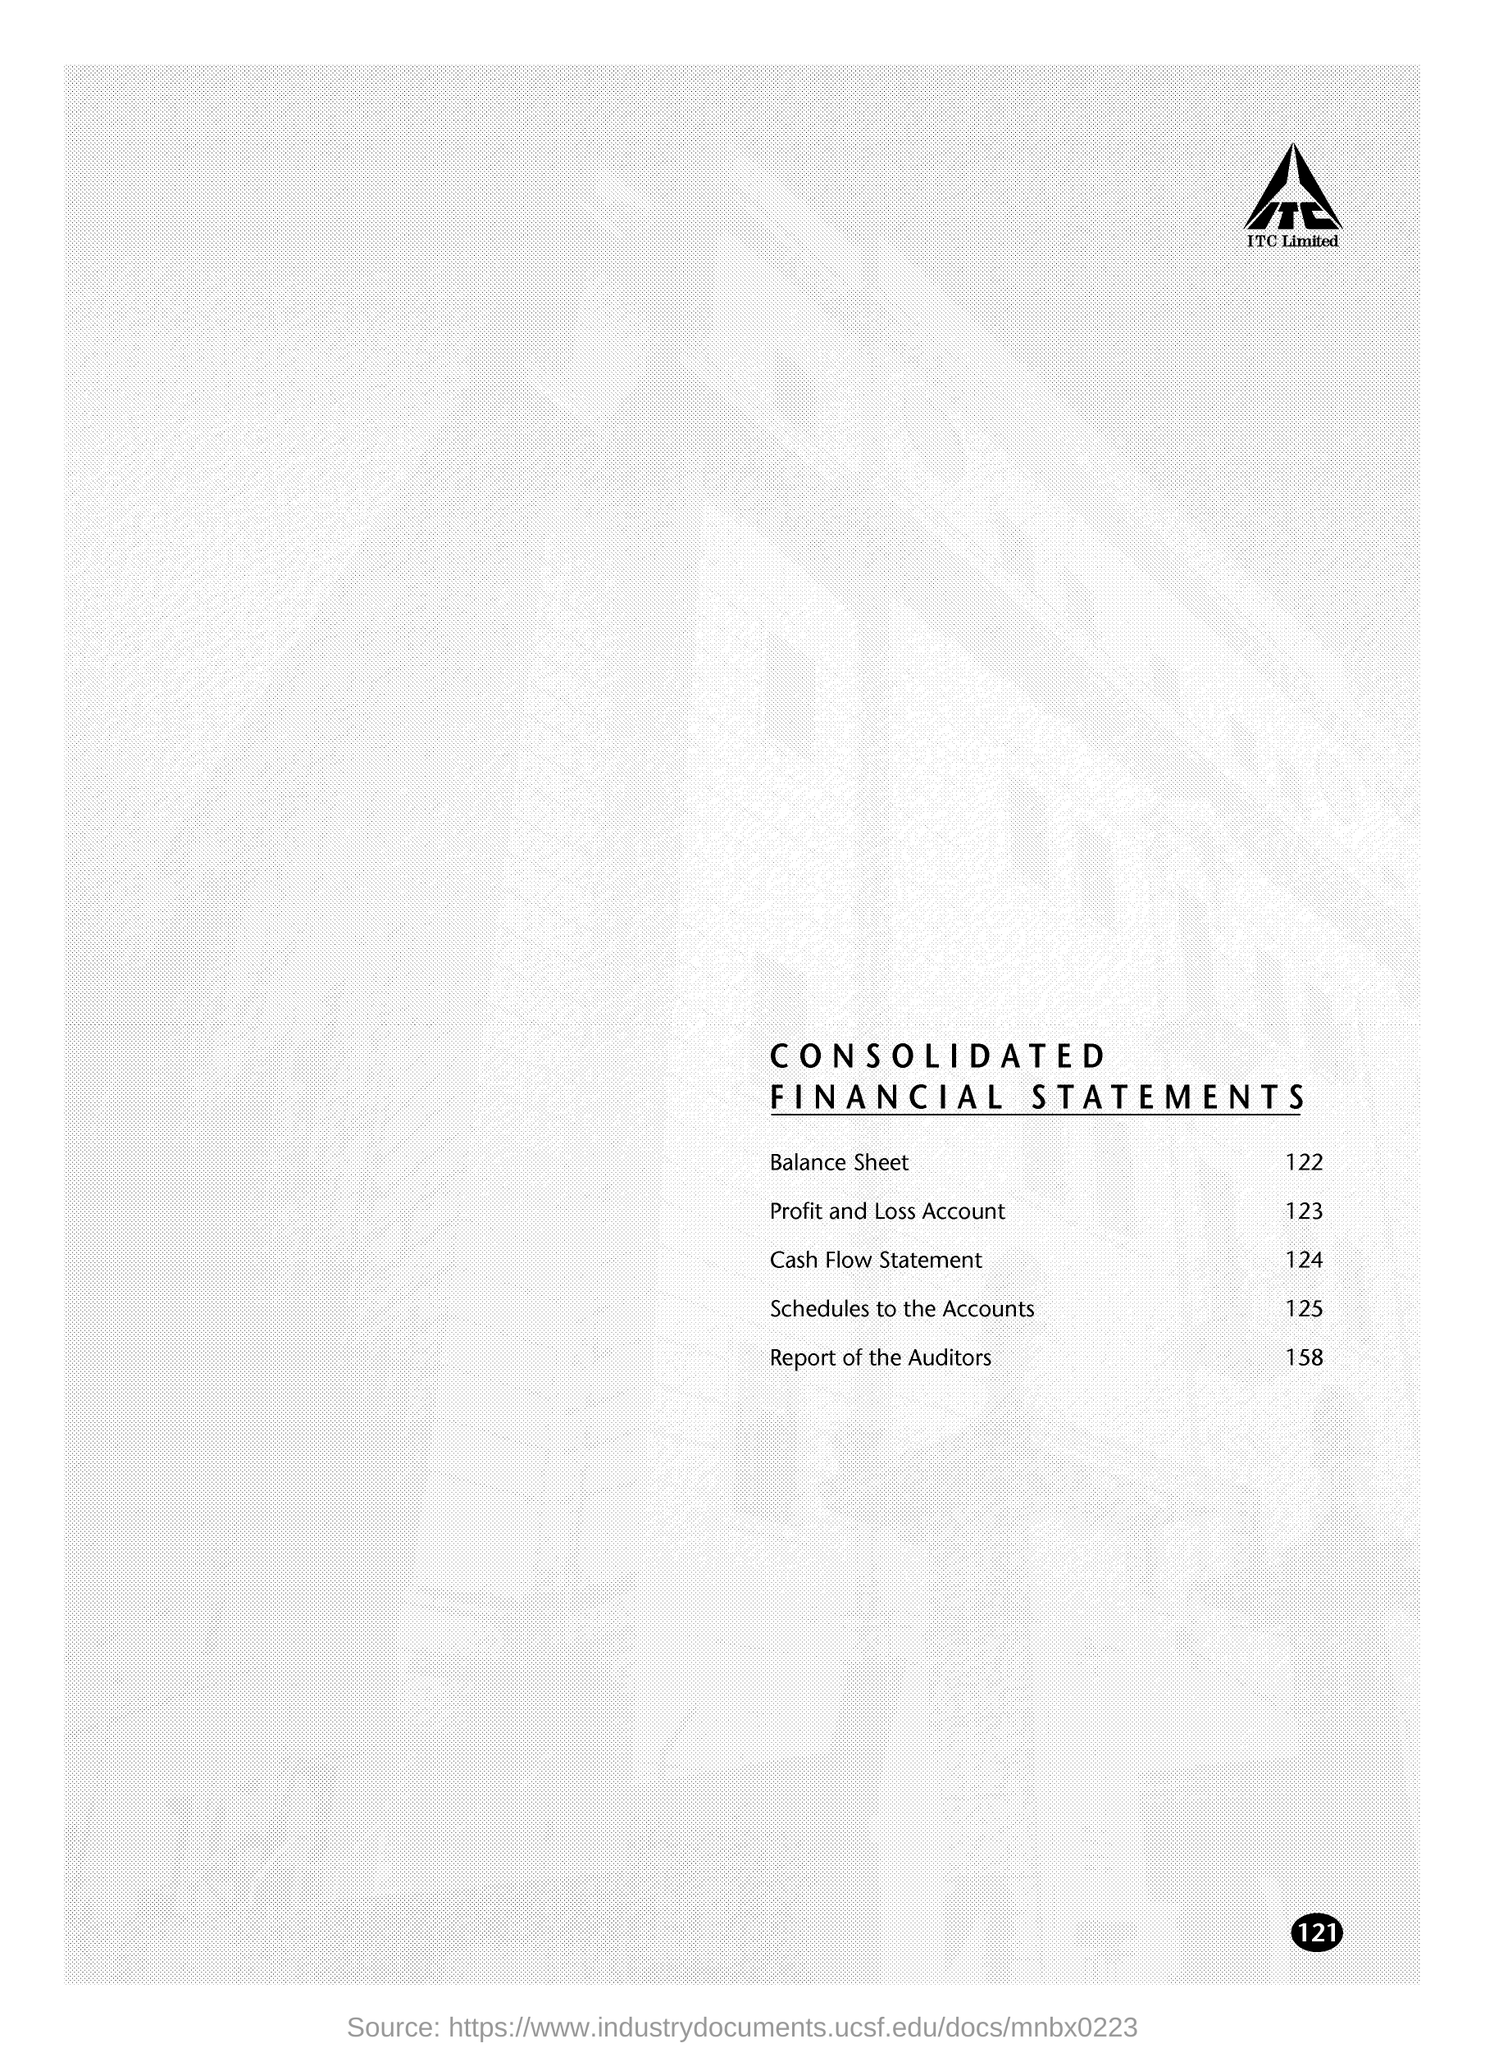Specify some key components in this picture. The page number on this document is 121," stated the speaker. The company whose name is displayed at the top of the page is ITC. Where can the Profit and Loss Account be found? It can be found on page 123. The report on page 158 is the report of the auditors. The document title is 'Consolidated Financial Statements'. 